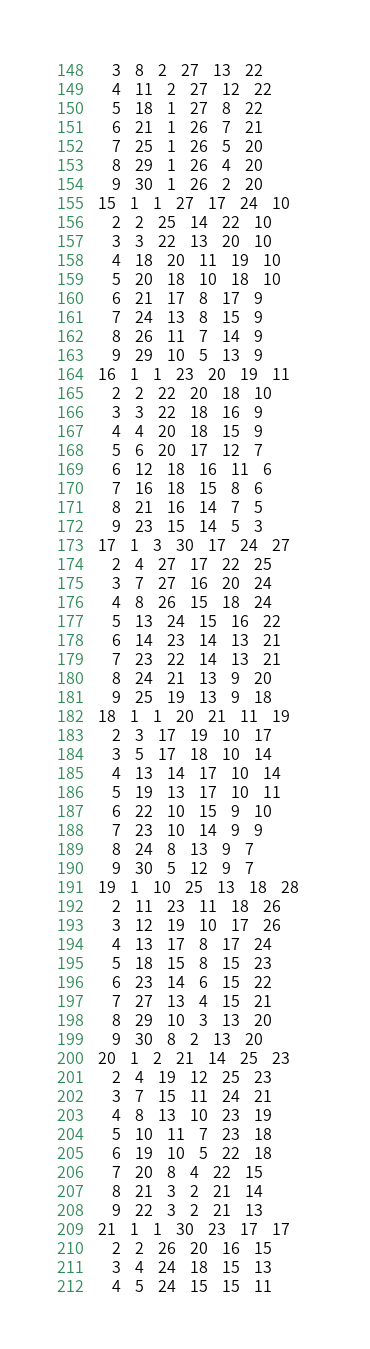<code> <loc_0><loc_0><loc_500><loc_500><_ObjectiveC_>	3	8	2	27	13	22	
	4	11	2	27	12	22	
	5	18	1	27	8	22	
	6	21	1	26	7	21	
	7	25	1	26	5	20	
	8	29	1	26	4	20	
	9	30	1	26	2	20	
15	1	1	27	17	24	10	
	2	2	25	14	22	10	
	3	3	22	13	20	10	
	4	18	20	11	19	10	
	5	20	18	10	18	10	
	6	21	17	8	17	9	
	7	24	13	8	15	9	
	8	26	11	7	14	9	
	9	29	10	5	13	9	
16	1	1	23	20	19	11	
	2	2	22	20	18	10	
	3	3	22	18	16	9	
	4	4	20	18	15	9	
	5	6	20	17	12	7	
	6	12	18	16	11	6	
	7	16	18	15	8	6	
	8	21	16	14	7	5	
	9	23	15	14	5	3	
17	1	3	30	17	24	27	
	2	4	27	17	22	25	
	3	7	27	16	20	24	
	4	8	26	15	18	24	
	5	13	24	15	16	22	
	6	14	23	14	13	21	
	7	23	22	14	13	21	
	8	24	21	13	9	20	
	9	25	19	13	9	18	
18	1	1	20	21	11	19	
	2	3	17	19	10	17	
	3	5	17	18	10	14	
	4	13	14	17	10	14	
	5	19	13	17	10	11	
	6	22	10	15	9	10	
	7	23	10	14	9	9	
	8	24	8	13	9	7	
	9	30	5	12	9	7	
19	1	10	25	13	18	28	
	2	11	23	11	18	26	
	3	12	19	10	17	26	
	4	13	17	8	17	24	
	5	18	15	8	15	23	
	6	23	14	6	15	22	
	7	27	13	4	15	21	
	8	29	10	3	13	20	
	9	30	8	2	13	20	
20	1	2	21	14	25	23	
	2	4	19	12	25	23	
	3	7	15	11	24	21	
	4	8	13	10	23	19	
	5	10	11	7	23	18	
	6	19	10	5	22	18	
	7	20	8	4	22	15	
	8	21	3	2	21	14	
	9	22	3	2	21	13	
21	1	1	30	23	17	17	
	2	2	26	20	16	15	
	3	4	24	18	15	13	
	4	5	24	15	15	11	</code> 